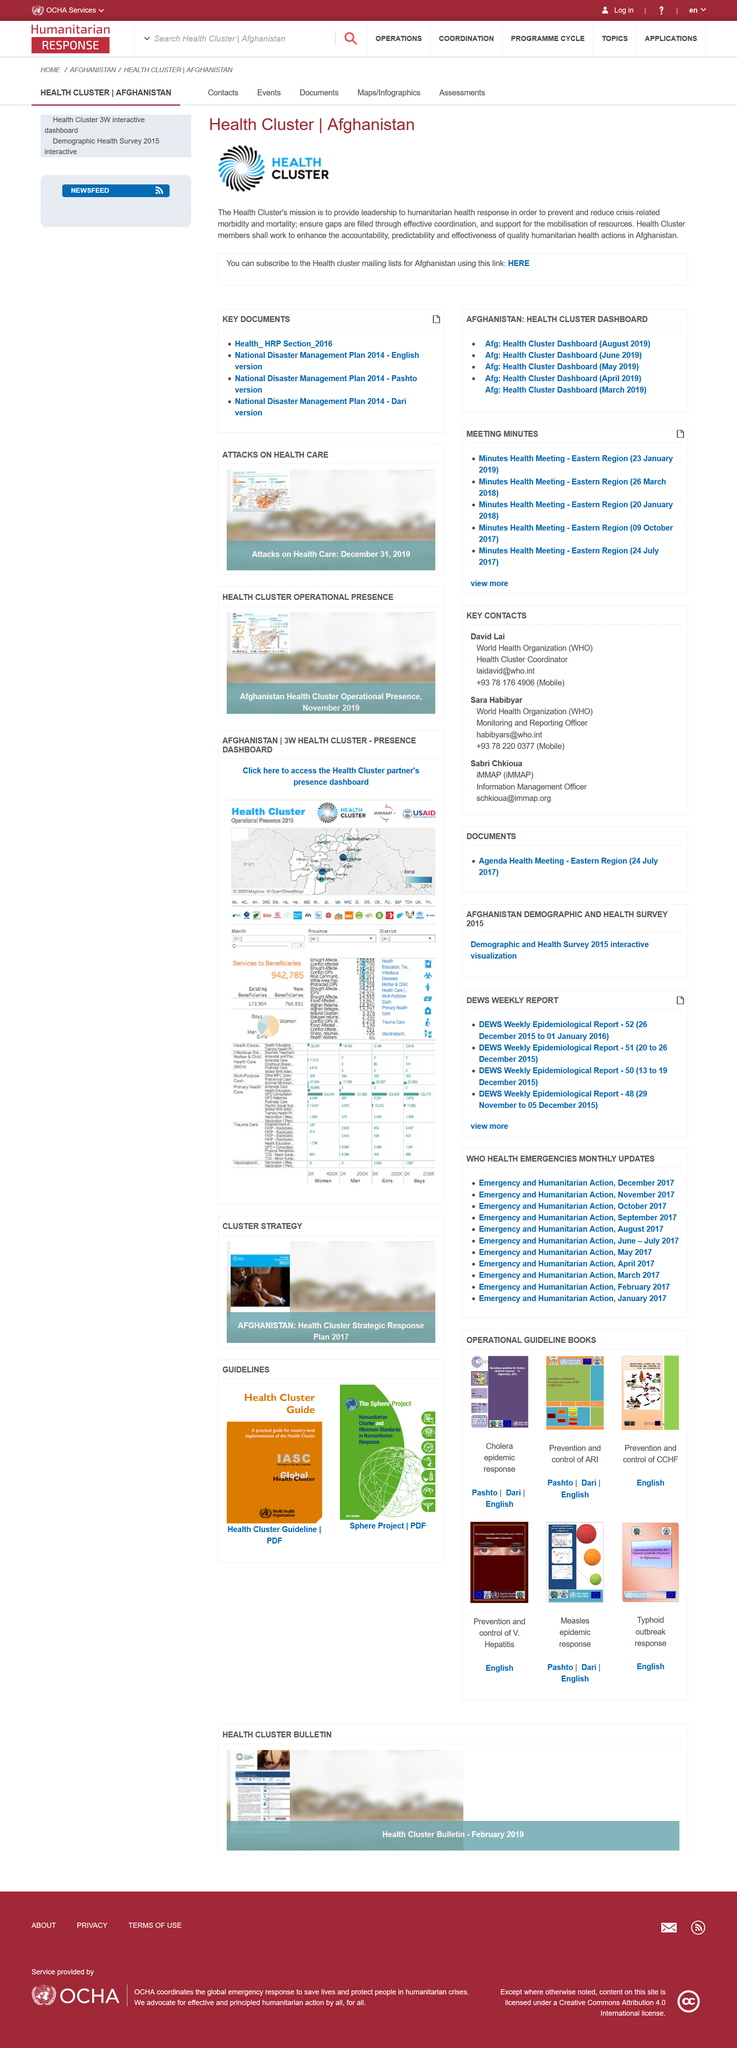Highlight a few significant elements in this photo. The Health Cluster members will work to enhance the accountability, predictability, and effectiveness of quality humanitarian health actions in Afghanistan. The Health Cluster logo utilizes blue and black colors, which are consistent with the branding guidelines established by the organization. 